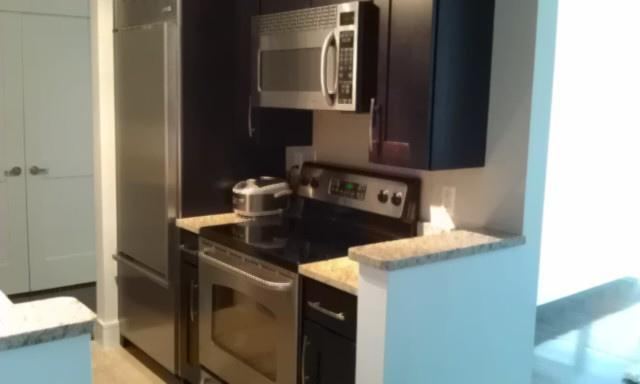What are the appliances made of?

Choices:
A) glass
B) plastic
C) steel
D) wood steel 